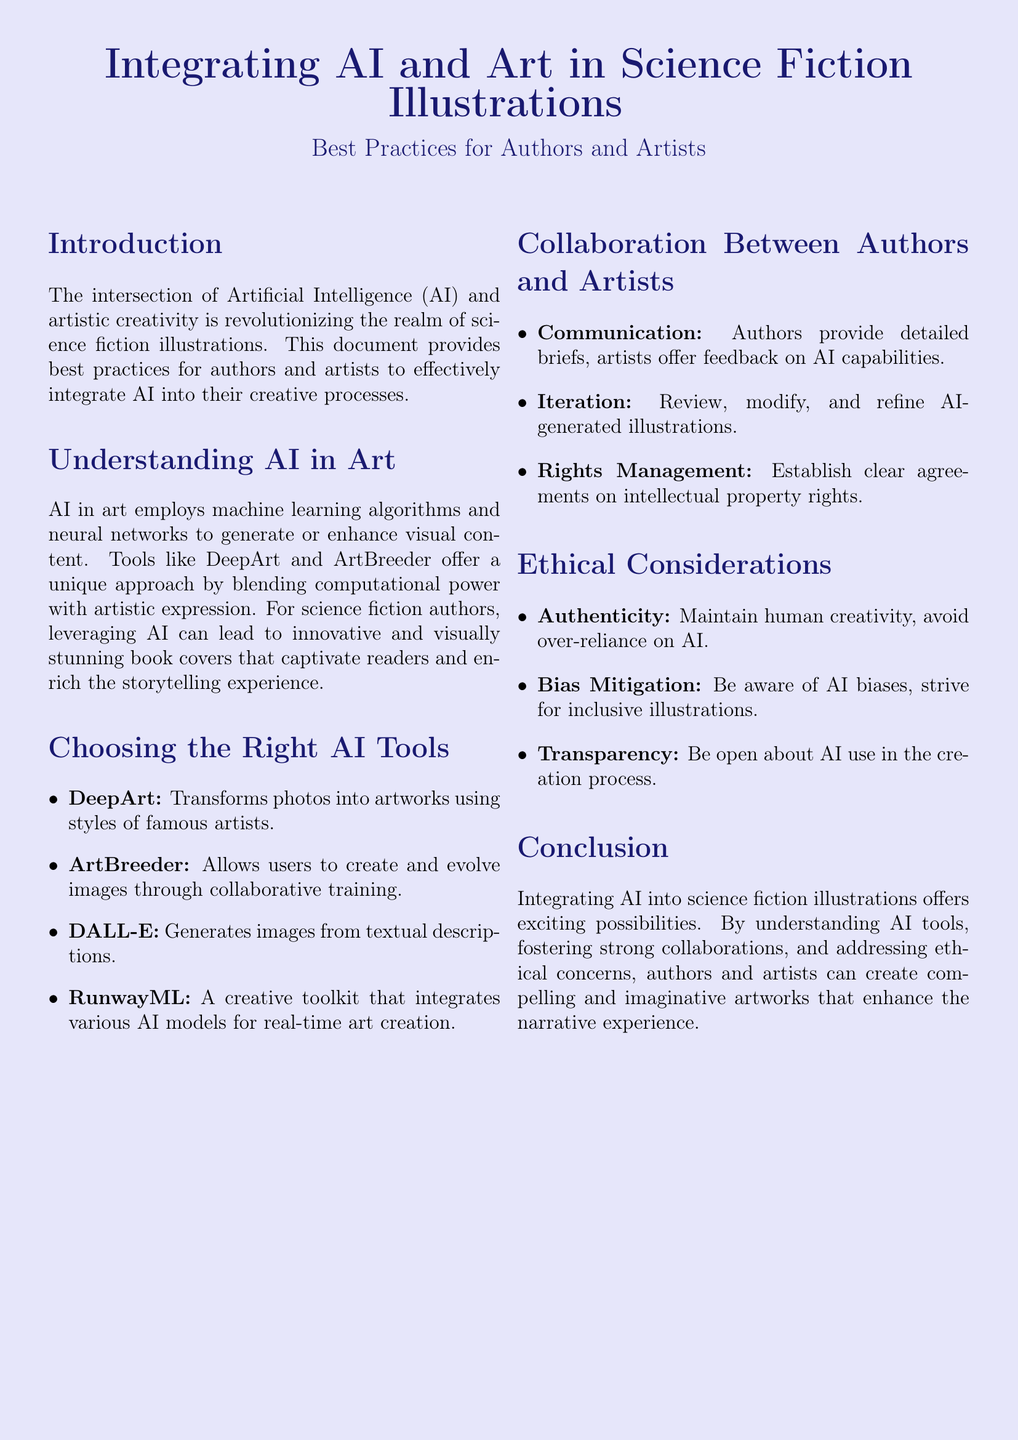What is the main focus of the document? The document focuses on the integration of AI and artistic creativity in science fiction illustrations.
Answer: Integration of AI and artistic creativity in science fiction illustrations What tool transforms photos into artworks using famous artist styles? The document lists DeepArt as a tool that transforms photos into artworks using the styles of famous artists.
Answer: DeepArt What should authors provide to artists for effective collaboration? Authors should provide detailed briefs to artists for effective collaboration.
Answer: Detailed briefs Which ethical consideration emphasizes avoiding over-reliance on AI? The document highlights the ethical consideration of maintaining human creativity and avoiding over-reliance on AI.
Answer: Authenticity What is a recommended practice for managing rights? Establishing clear agreements on intellectual property rights is a recommended practice for managing rights.
Answer: Clear agreements on intellectual property rights How many AI tools are mentioned in the document? The document lists four different AI tools available for art creation, hence the answer is four.
Answer: Four What is the purpose of using AI according to the document? The purpose of using AI is to create compelling and imaginative artworks that enhance the narrative experience.
Answer: Create compelling and imaginative artworks What are authors encouraged to do in the collaboration process? Authors are encouraged to review, modify, and refine AI-generated illustrations in the collaboration process.
Answer: Review, modify, and refine 